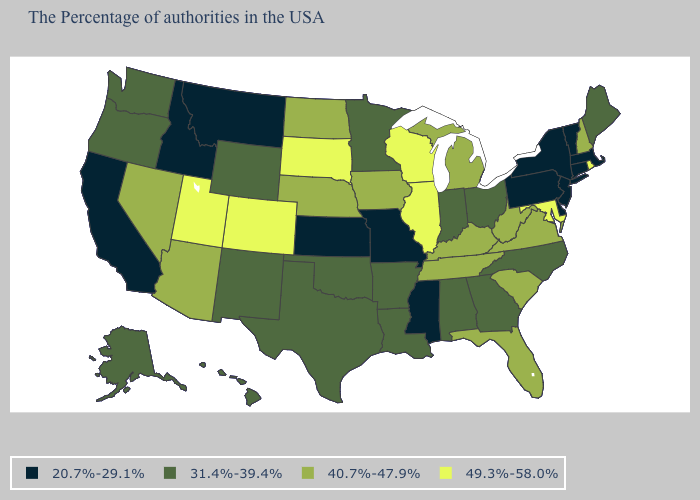What is the value of Kentucky?
Concise answer only. 40.7%-47.9%. Name the states that have a value in the range 20.7%-29.1%?
Short answer required. Massachusetts, Vermont, Connecticut, New York, New Jersey, Delaware, Pennsylvania, Mississippi, Missouri, Kansas, Montana, Idaho, California. What is the value of Delaware?
Short answer required. 20.7%-29.1%. What is the lowest value in the USA?
Answer briefly. 20.7%-29.1%. Name the states that have a value in the range 31.4%-39.4%?
Give a very brief answer. Maine, North Carolina, Ohio, Georgia, Indiana, Alabama, Louisiana, Arkansas, Minnesota, Oklahoma, Texas, Wyoming, New Mexico, Washington, Oregon, Alaska, Hawaii. Name the states that have a value in the range 20.7%-29.1%?
Write a very short answer. Massachusetts, Vermont, Connecticut, New York, New Jersey, Delaware, Pennsylvania, Mississippi, Missouri, Kansas, Montana, Idaho, California. What is the value of Mississippi?
Short answer required. 20.7%-29.1%. Name the states that have a value in the range 49.3%-58.0%?
Answer briefly. Rhode Island, Maryland, Wisconsin, Illinois, South Dakota, Colorado, Utah. Which states hav the highest value in the Northeast?
Quick response, please. Rhode Island. Among the states that border New Hampshire , which have the highest value?
Keep it brief. Maine. Among the states that border Kentucky , does Missouri have the lowest value?
Give a very brief answer. Yes. Which states hav the highest value in the MidWest?
Write a very short answer. Wisconsin, Illinois, South Dakota. Does the map have missing data?
Quick response, please. No. What is the value of Wisconsin?
Give a very brief answer. 49.3%-58.0%. Does New Hampshire have a lower value than Hawaii?
Quick response, please. No. 